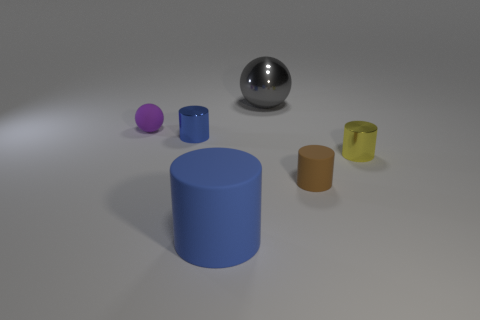Are there any large brown things? Yes, there is one large brown cylindrical object towards the right side of the image. 